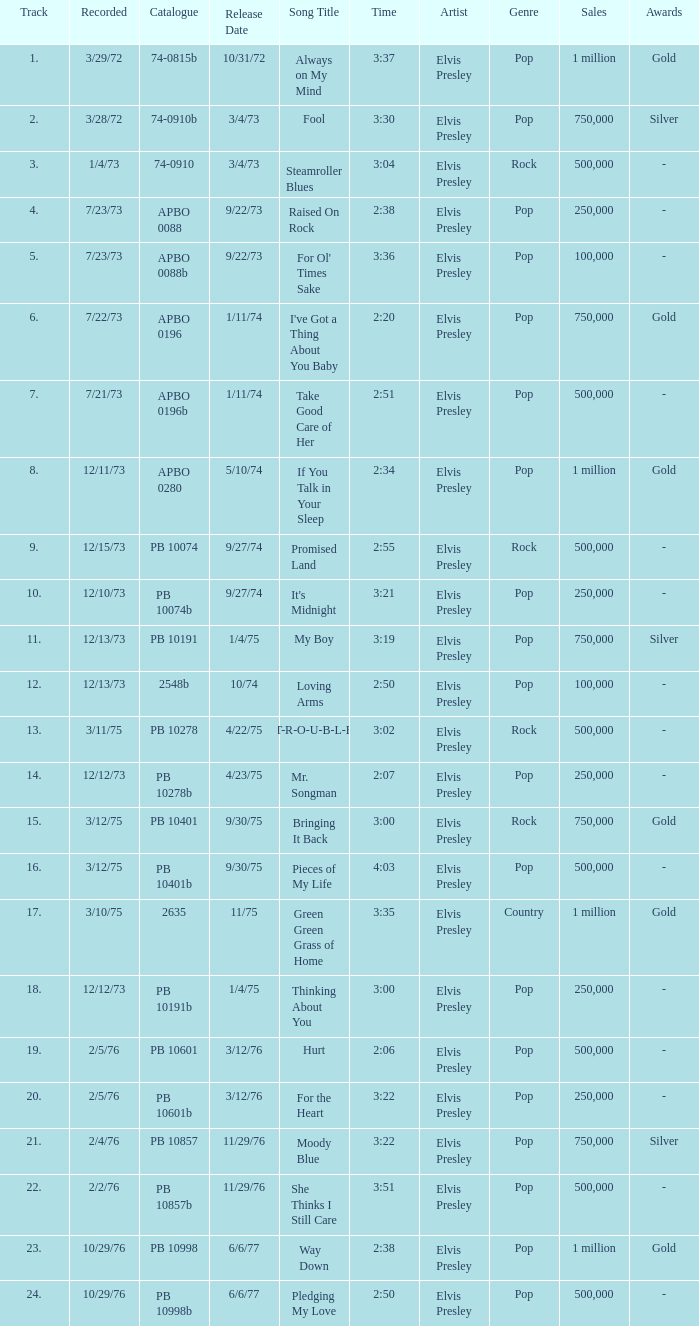Name the catalogue that has tracks less than 13 and the release date of 10/31/72 74-0815b. 